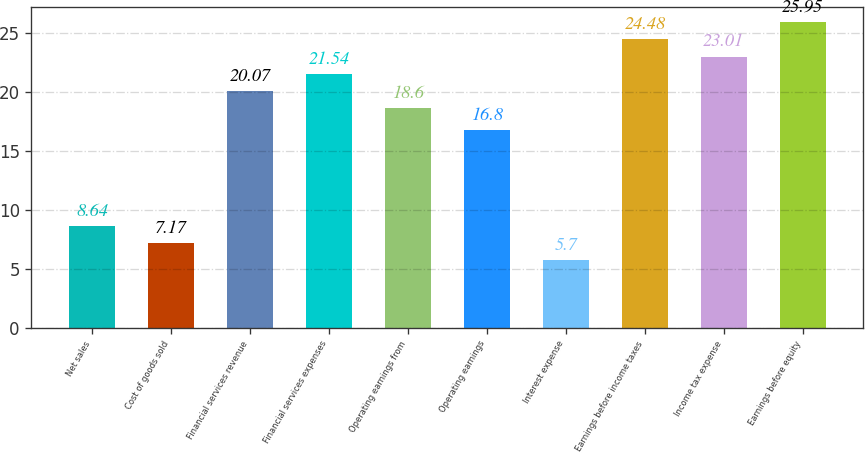Convert chart. <chart><loc_0><loc_0><loc_500><loc_500><bar_chart><fcel>Net sales<fcel>Cost of goods sold<fcel>Financial services revenue<fcel>Financial services expenses<fcel>Operating earnings from<fcel>Operating earnings<fcel>Interest expense<fcel>Earnings before income taxes<fcel>Income tax expense<fcel>Earnings before equity<nl><fcel>8.64<fcel>7.17<fcel>20.07<fcel>21.54<fcel>18.6<fcel>16.8<fcel>5.7<fcel>24.48<fcel>23.01<fcel>25.95<nl></chart> 